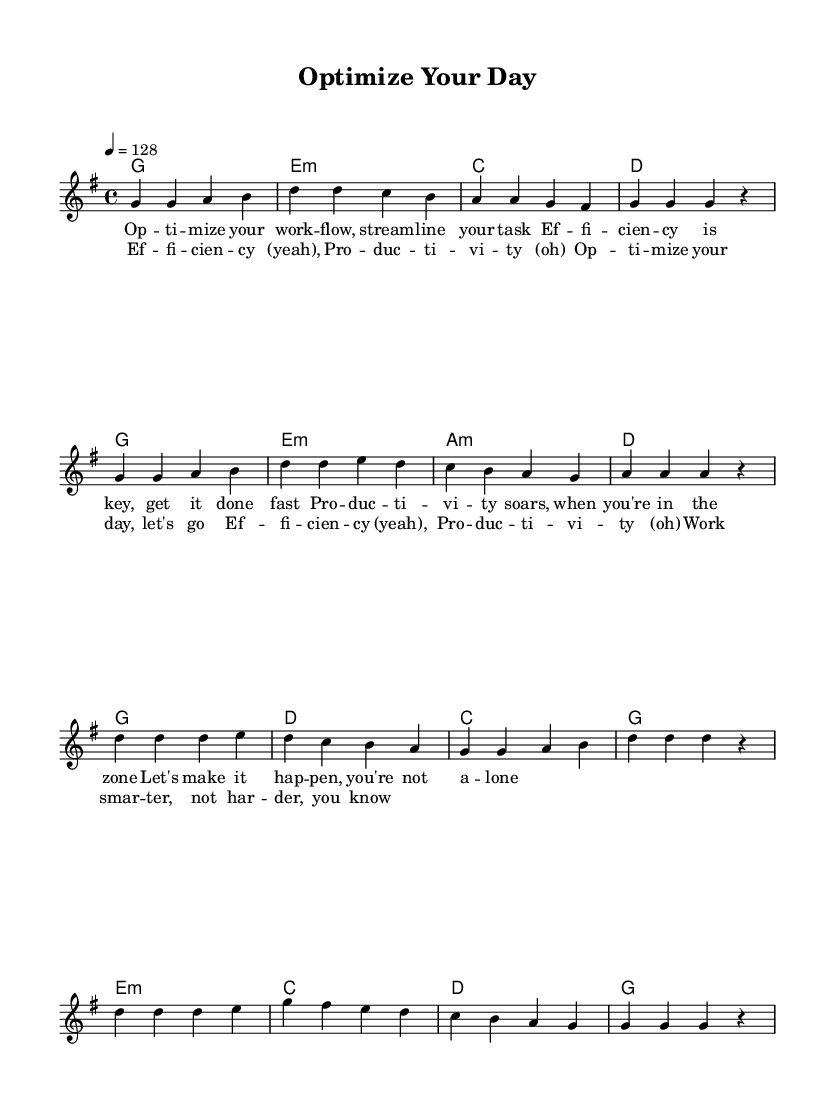What is the key signature of this music? The key signature is G major, which has one sharp (F#). We determine this by looking for sharps or flats at the beginning of the staff. In this case, only F# is present.
Answer: G major What is the time signature of this music? The time signature is 4/4, as indicated at the beginning of the staff. This means there are four beats in each measure, and a quarter note gets one beat.
Answer: 4/4 What is the tempo of this piece? The tempo marking indicates a speed of 128 beats per minute. This is often specified at the beginning of the score, where it reads “4 = 128.”
Answer: 128 How many measures are in the chorus section? The chorus section consists of 8 measures. We can count the measures by identifying the vertical lines (bar lines) that divide the music into sections.
Answer: 8 What are the first lyrics sung in the verse? The first lyrics are "Optimize your work." This is determined by looking at the lyrics written below the melody, aligning with the first notes played.
Answer: Optimize your work Which part of the song features the line "Work smarter, not harder"? This line is part of the chorus lyrics, which are repeated after the verse. We identify it by looking for that specific phrase in the chorus lyrics section.
Answer: Chorus How does the harmony change between the verse and the chorus? The harmony in the verse primarily alternates between G, E minor, and D, whereas in the chorus, it shifts to a simpler pattern focusing more on G, D, and C. This requires analyzing the chords written above the melody in both sections.
Answer: Different chord patterns 